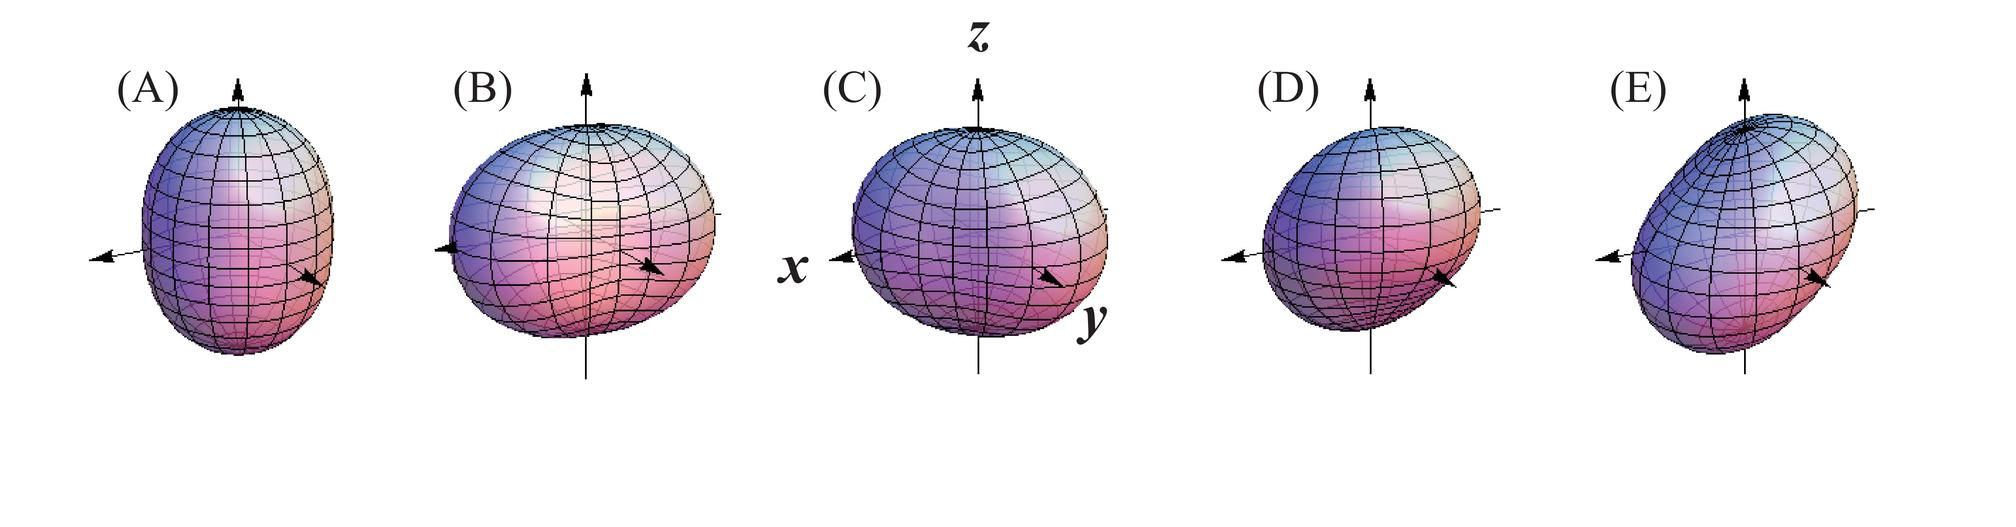Could you explain the possible real-world applications of studying these deformation patterns? Studying deformation patterns is crucial in fields like material science, mechanical engineering, and civil engineering. It allows for the prediction and analysis of how materials will behave under various loads, which is vital for the design and safety of structures such as bridges, buildings, automotive components, and even in creating resilient aerospace materials. Understanding these patterns also informs the development of new materials with desired properties for specific applications. 